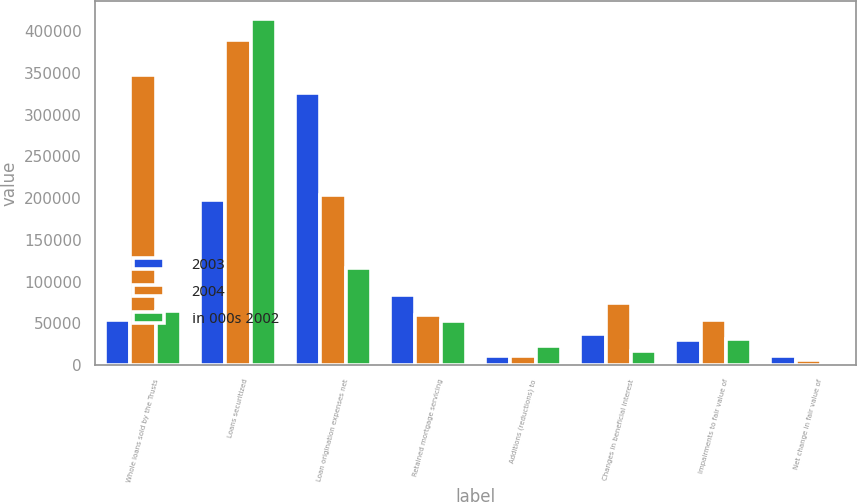<chart> <loc_0><loc_0><loc_500><loc_500><stacked_bar_chart><ecel><fcel>Whole loans sold by the Trusts<fcel>Loans securitized<fcel>Loan origination expenses net<fcel>Retained mortgage servicing<fcel>Additions (reductions) to<fcel>Changes in beneficial interest<fcel>Impairments to fair value of<fcel>Net change in fair value of<nl><fcel>2003<fcel>54111<fcel>198226<fcel>325605<fcel>84274<fcel>11490<fcel>37918<fcel>30661<fcel>11570<nl><fcel>2004<fcel>347241<fcel>389449<fcel>203511<fcel>60078<fcel>10829<fcel>74987<fcel>54111<fcel>6158<nl><fcel>in 000s 2002<fcel>65219<fcel>414844<fcel>116699<fcel>52844<fcel>22910<fcel>17028<fcel>30987<fcel>758<nl></chart> 